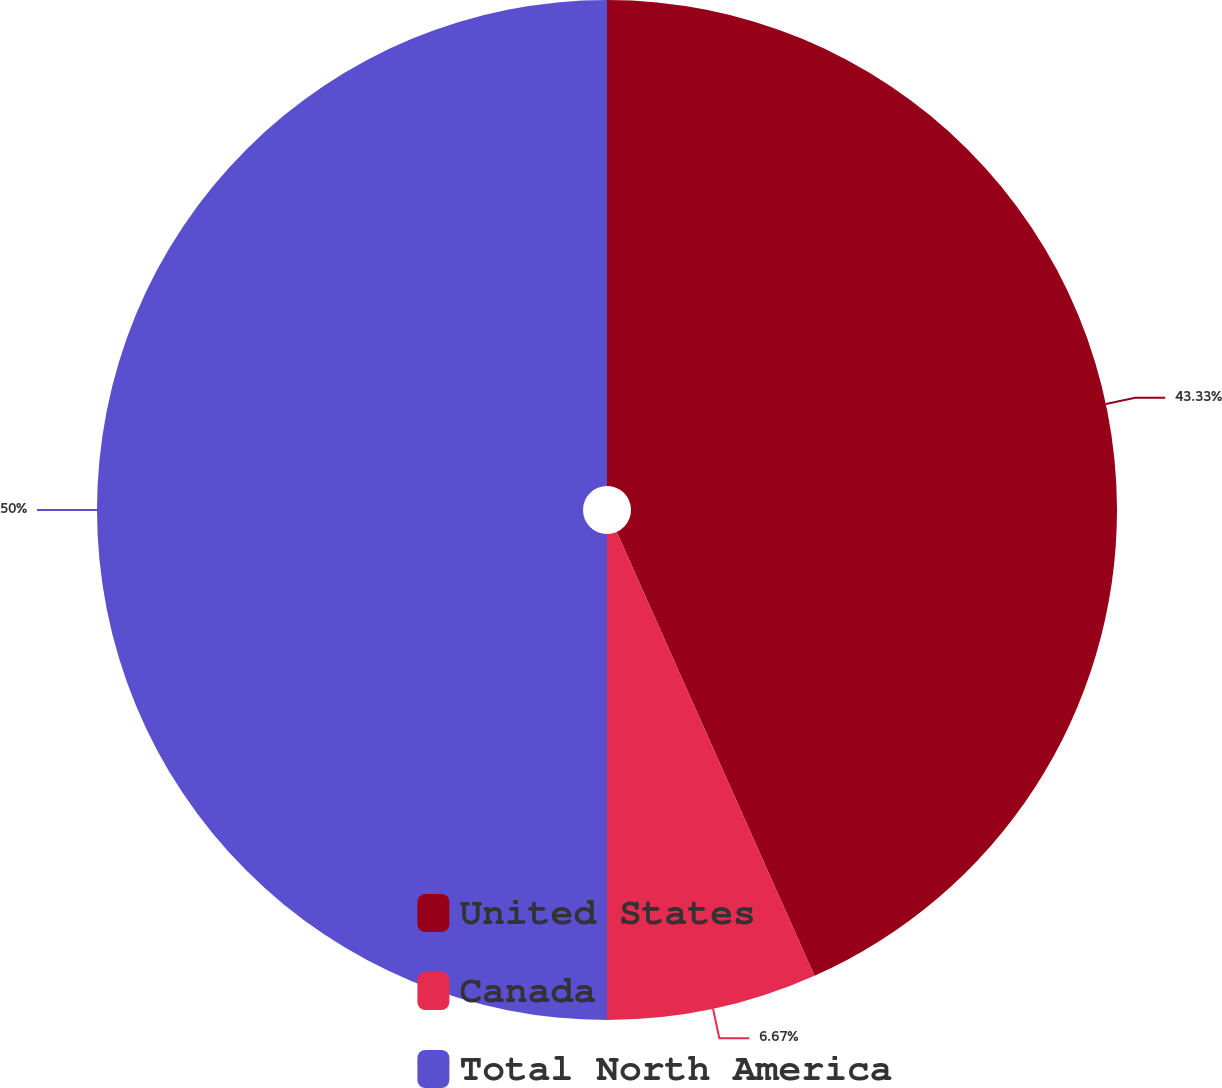Convert chart to OTSL. <chart><loc_0><loc_0><loc_500><loc_500><pie_chart><fcel>United States<fcel>Canada<fcel>Total North America<nl><fcel>43.33%<fcel>6.67%<fcel>50.0%<nl></chart> 